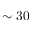<formula> <loc_0><loc_0><loc_500><loc_500>\sim 3 0</formula> 